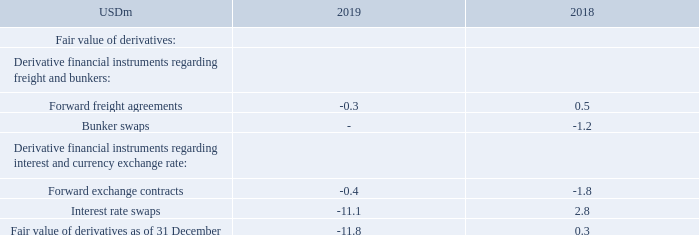NOTE 19 – DERIVATIVE FINANCIAL INSTRUMENTS
Please refer to note 21 “Financial Instruments” for further information on fair value hierarchies.
What information is provided in Note 21? Further information on fair value hierarchies. What are the types of derivative financial instruments regarding freight and bunkers? Forward freight agreements, bunker swaps. What are the types of derivative financial instruments regarding interest and currency exchange rate? Forward exchange contracts, interest rate swaps. In which year was the amount of forward exchange contracts larger? |1.8|>|0.4|
Answer: 2018. What was the change in interest rate swaps from 2018 to 2019?
Answer scale should be: million. -11.1-2.8
Answer: -13.9. What was the percentage change in interest rate swaps from 2018 to 2019?
Answer scale should be: percent. (-11.1-2.8)/2.8
Answer: -496.43. 